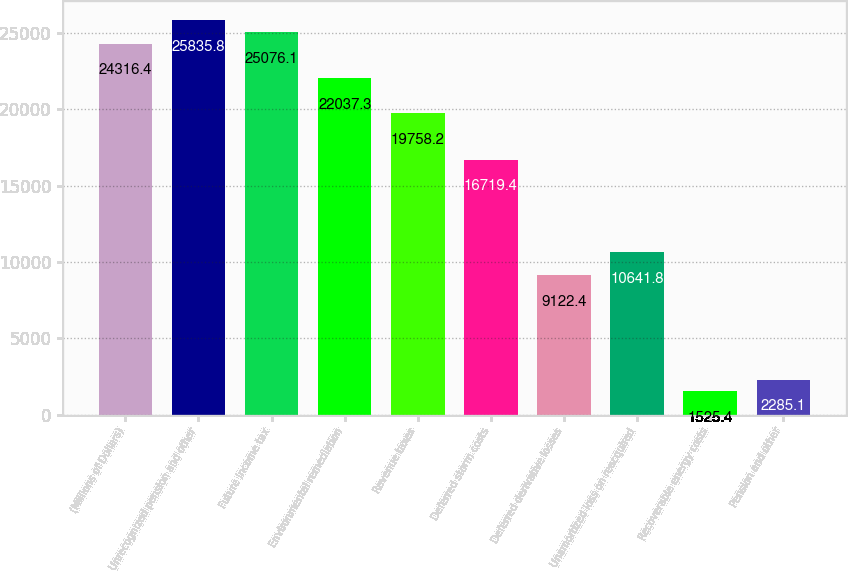Convert chart. <chart><loc_0><loc_0><loc_500><loc_500><bar_chart><fcel>(Millions of Dollars)<fcel>Unrecognized pension and other<fcel>Future income tax<fcel>Environmental remediation<fcel>Revenue taxes<fcel>Deferred storm costs<fcel>Deferred derivative losses<fcel>Unamortized loss on reacquired<fcel>Recoverable energy costs<fcel>Pension and other<nl><fcel>24316.4<fcel>25835.8<fcel>25076.1<fcel>22037.3<fcel>19758.2<fcel>16719.4<fcel>9122.4<fcel>10641.8<fcel>1525.4<fcel>2285.1<nl></chart> 